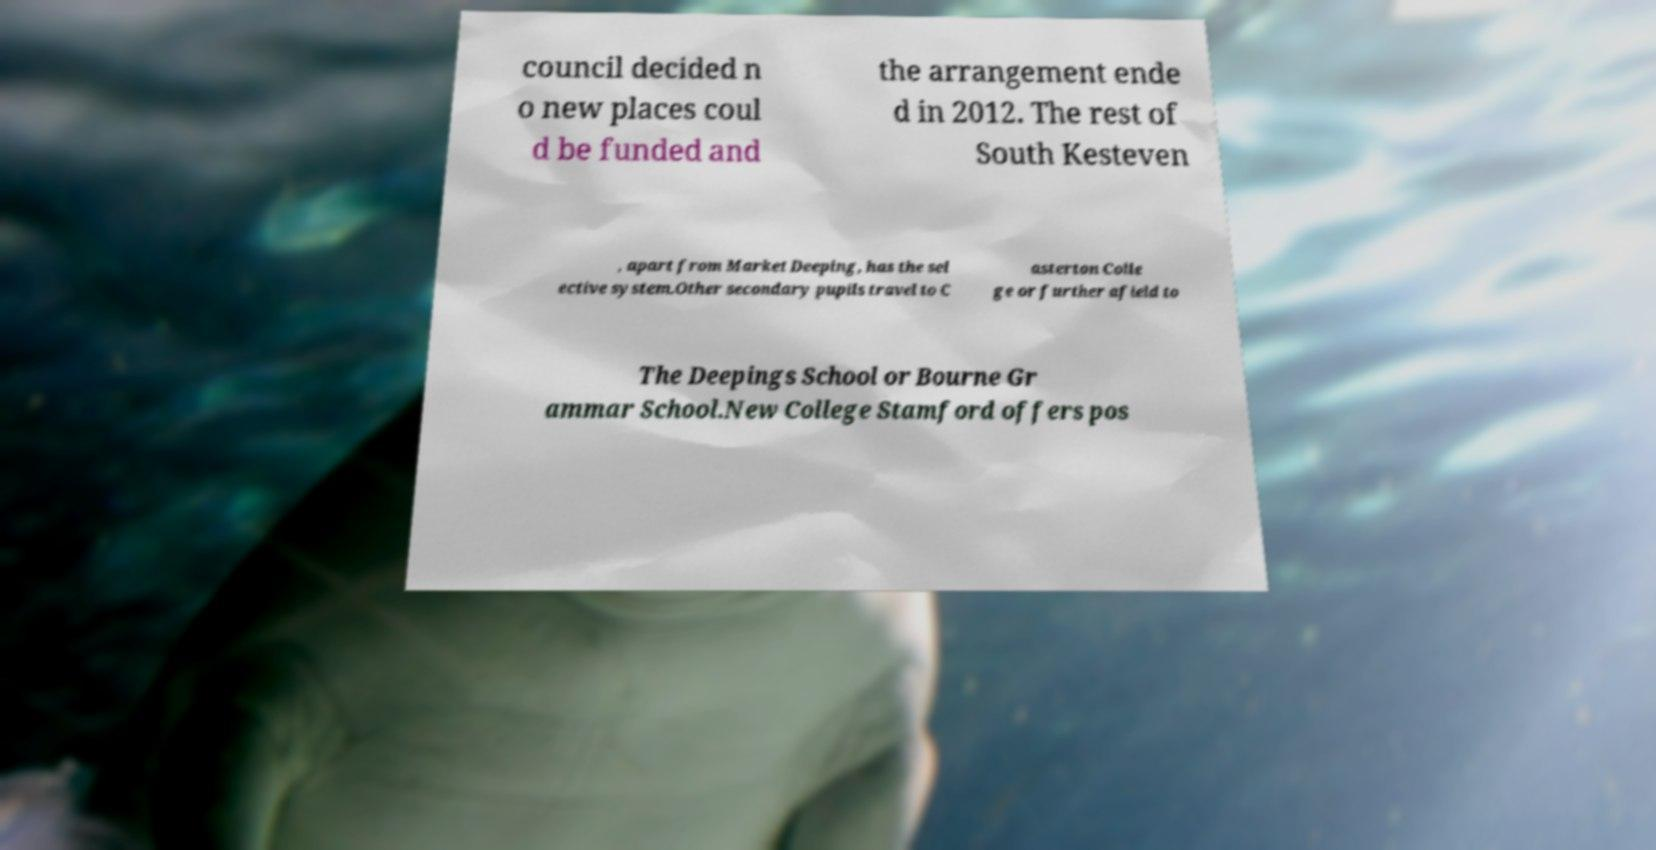For documentation purposes, I need the text within this image transcribed. Could you provide that? council decided n o new places coul d be funded and the arrangement ende d in 2012. The rest of South Kesteven , apart from Market Deeping, has the sel ective system.Other secondary pupils travel to C asterton Colle ge or further afield to The Deepings School or Bourne Gr ammar School.New College Stamford offers pos 